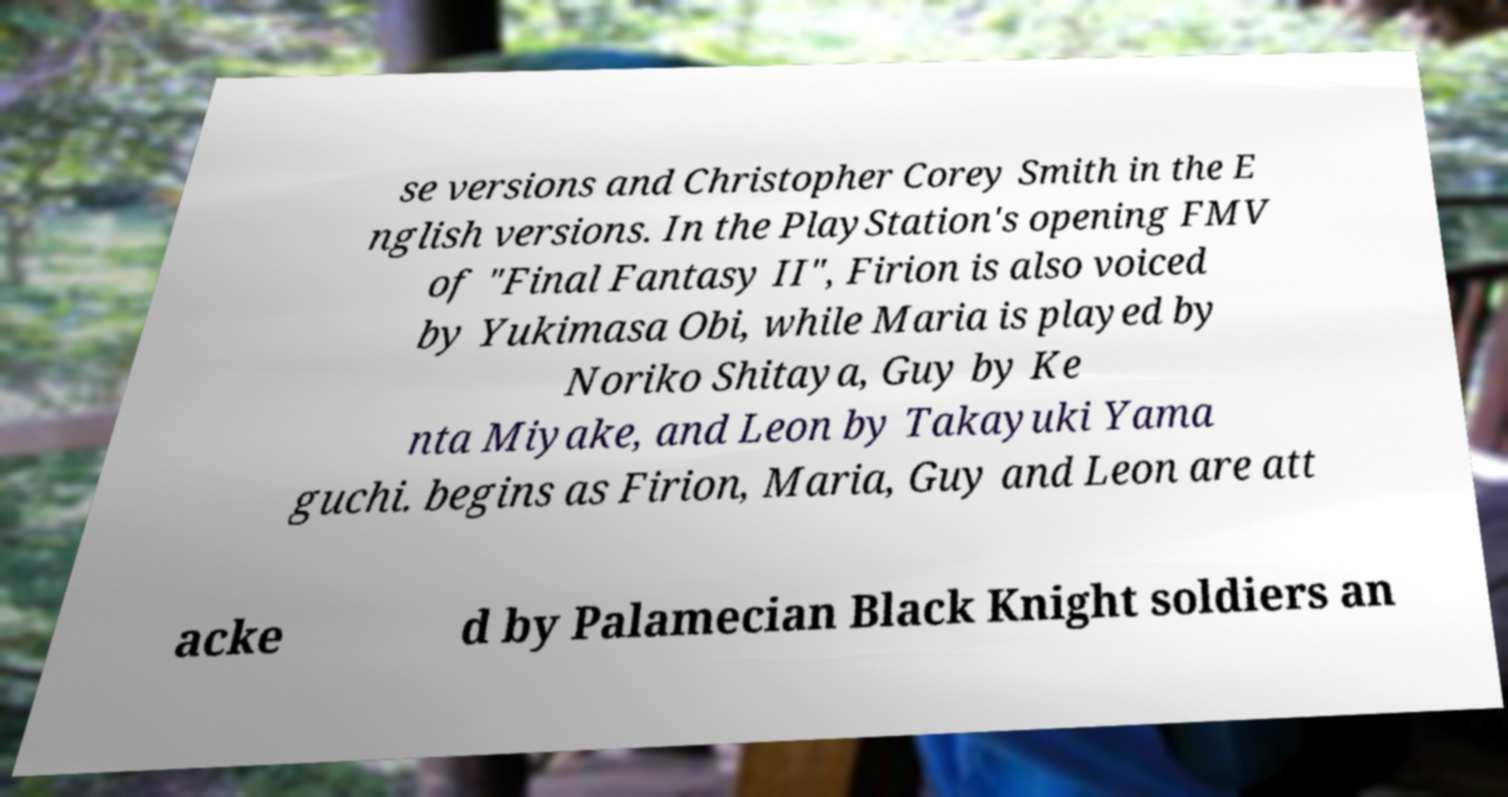Please read and relay the text visible in this image. What does it say? se versions and Christopher Corey Smith in the E nglish versions. In the PlayStation's opening FMV of "Final Fantasy II", Firion is also voiced by Yukimasa Obi, while Maria is played by Noriko Shitaya, Guy by Ke nta Miyake, and Leon by Takayuki Yama guchi. begins as Firion, Maria, Guy and Leon are att acke d by Palamecian Black Knight soldiers an 